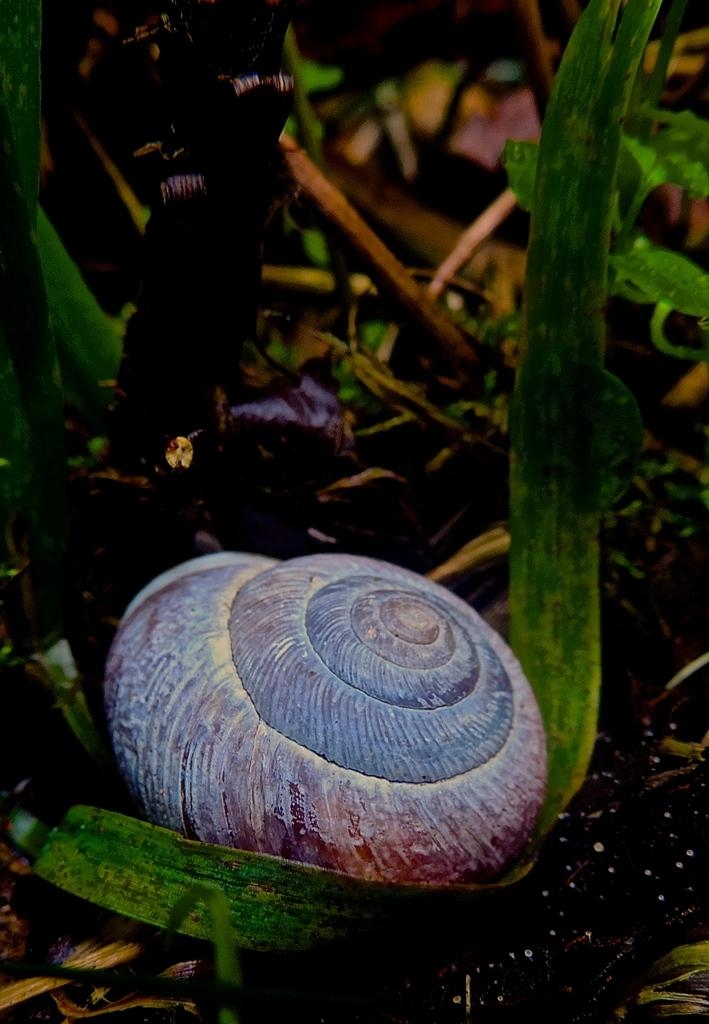What is the main object in the image? There is a shell in the image. What else can be seen in the image besides the shell? There are sticks and plants visible in the image. How many hands are visible in the image? There are no hands visible in the image. What color is the eye in the image? There is no eye present in the image. 